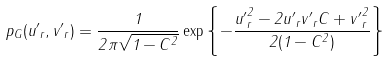Convert formula to latex. <formula><loc_0><loc_0><loc_500><loc_500>p _ { G } ( { u ^ { \prime } } _ { r } , { v ^ { \prime } } _ { r } ) = \frac { 1 } { 2 \pi \sqrt { 1 - C ^ { 2 } } } \exp { \left \{ - \frac { { u ^ { \prime } } _ { r } ^ { 2 } - 2 { u ^ { \prime } } _ { r } { v ^ { \prime } } _ { r } C + { v ^ { \prime } } _ { r } ^ { 2 } } { 2 ( 1 - C ^ { 2 } ) } \right \} }</formula> 